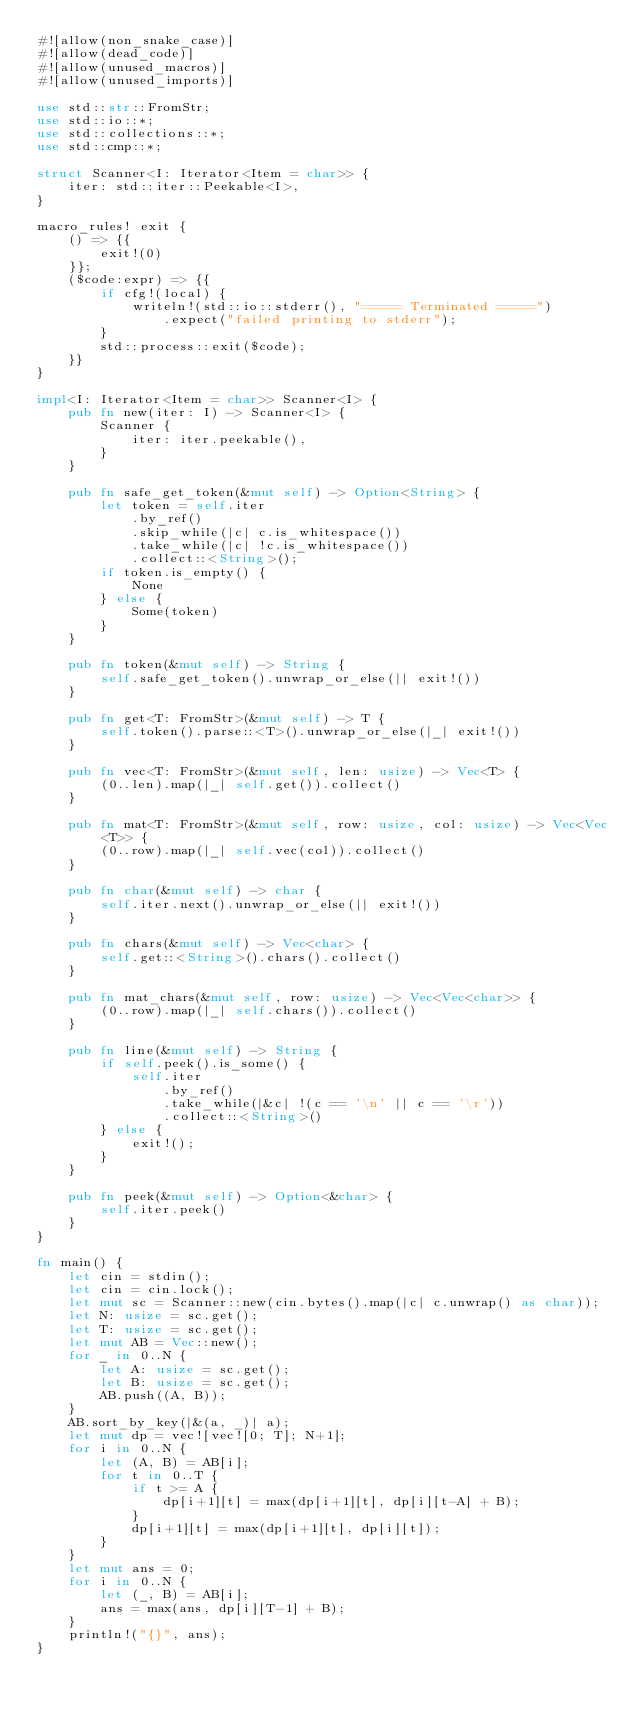<code> <loc_0><loc_0><loc_500><loc_500><_Rust_>#![allow(non_snake_case)]
#![allow(dead_code)]
#![allow(unused_macros)]
#![allow(unused_imports)]

use std::str::FromStr;
use std::io::*;
use std::collections::*;
use std::cmp::*;

struct Scanner<I: Iterator<Item = char>> {
    iter: std::iter::Peekable<I>,
}

macro_rules! exit {
    () => {{
        exit!(0)
    }};
    ($code:expr) => {{
        if cfg!(local) {
            writeln!(std::io::stderr(), "===== Terminated =====")
                .expect("failed printing to stderr");
        }
        std::process::exit($code);
    }}
}

impl<I: Iterator<Item = char>> Scanner<I> {
    pub fn new(iter: I) -> Scanner<I> {
        Scanner {
            iter: iter.peekable(),
        }
    }

    pub fn safe_get_token(&mut self) -> Option<String> {
        let token = self.iter
            .by_ref()
            .skip_while(|c| c.is_whitespace())
            .take_while(|c| !c.is_whitespace())
            .collect::<String>();
        if token.is_empty() {
            None
        } else {
            Some(token)
        }
    }

    pub fn token(&mut self) -> String {
        self.safe_get_token().unwrap_or_else(|| exit!())
    }

    pub fn get<T: FromStr>(&mut self) -> T {
        self.token().parse::<T>().unwrap_or_else(|_| exit!())
    }

    pub fn vec<T: FromStr>(&mut self, len: usize) -> Vec<T> {
        (0..len).map(|_| self.get()).collect()
    }

    pub fn mat<T: FromStr>(&mut self, row: usize, col: usize) -> Vec<Vec<T>> {
        (0..row).map(|_| self.vec(col)).collect()
    }

    pub fn char(&mut self) -> char {
        self.iter.next().unwrap_or_else(|| exit!())
    }

    pub fn chars(&mut self) -> Vec<char> {
        self.get::<String>().chars().collect()
    }

    pub fn mat_chars(&mut self, row: usize) -> Vec<Vec<char>> {
        (0..row).map(|_| self.chars()).collect()
    }

    pub fn line(&mut self) -> String {
        if self.peek().is_some() {
            self.iter
                .by_ref()
                .take_while(|&c| !(c == '\n' || c == '\r'))
                .collect::<String>()
        } else {
            exit!();
        }
    }

    pub fn peek(&mut self) -> Option<&char> {
        self.iter.peek()
    }
}

fn main() {
    let cin = stdin();
    let cin = cin.lock();
    let mut sc = Scanner::new(cin.bytes().map(|c| c.unwrap() as char));
    let N: usize = sc.get();
    let T: usize = sc.get();
    let mut AB = Vec::new();
    for _ in 0..N {
        let A: usize = sc.get();
        let B: usize = sc.get();
        AB.push((A, B));
    }
    AB.sort_by_key(|&(a, _)| a);
    let mut dp = vec![vec![0; T]; N+1];
    for i in 0..N {
        let (A, B) = AB[i];
        for t in 0..T {
            if t >= A {
                dp[i+1][t] = max(dp[i+1][t], dp[i][t-A] + B);
            }
            dp[i+1][t] = max(dp[i+1][t], dp[i][t]);
        }
    }
    let mut ans = 0;
    for i in 0..N {
        let (_, B) = AB[i];
        ans = max(ans, dp[i][T-1] + B);
    }
    println!("{}", ans);
}
</code> 